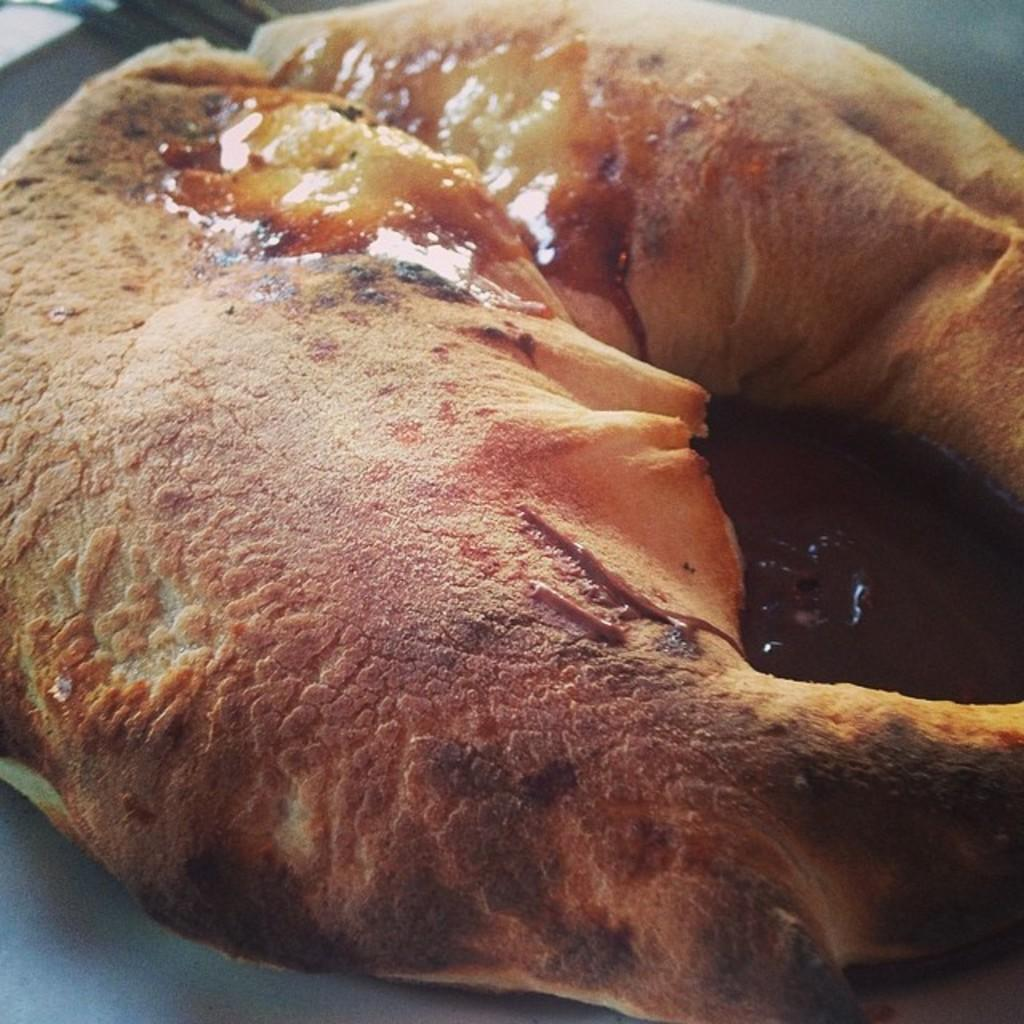What is the main subject of the image? There is a food item in the image. What is the color of the surface the food item is on? The food item is on a black surface. What colors can be seen on the food item? The food item has brown and cream colors. How many berries are present in the image? There is no mention of berries in the image, so it cannot be determined if any are present. 